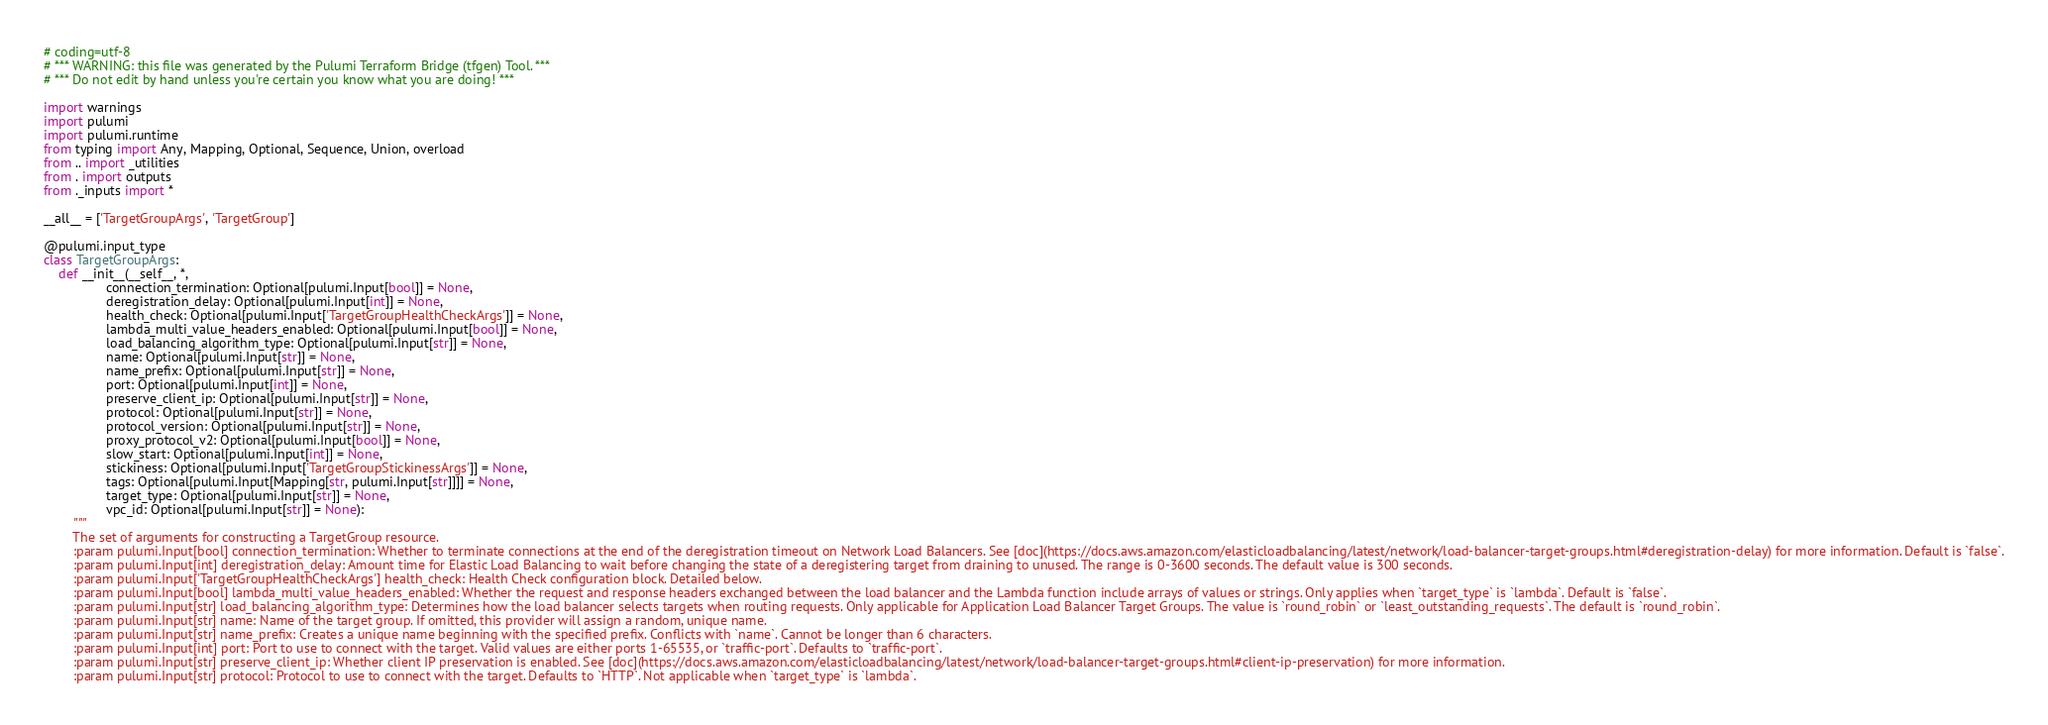Convert code to text. <code><loc_0><loc_0><loc_500><loc_500><_Python_># coding=utf-8
# *** WARNING: this file was generated by the Pulumi Terraform Bridge (tfgen) Tool. ***
# *** Do not edit by hand unless you're certain you know what you are doing! ***

import warnings
import pulumi
import pulumi.runtime
from typing import Any, Mapping, Optional, Sequence, Union, overload
from .. import _utilities
from . import outputs
from ._inputs import *

__all__ = ['TargetGroupArgs', 'TargetGroup']

@pulumi.input_type
class TargetGroupArgs:
    def __init__(__self__, *,
                 connection_termination: Optional[pulumi.Input[bool]] = None,
                 deregistration_delay: Optional[pulumi.Input[int]] = None,
                 health_check: Optional[pulumi.Input['TargetGroupHealthCheckArgs']] = None,
                 lambda_multi_value_headers_enabled: Optional[pulumi.Input[bool]] = None,
                 load_balancing_algorithm_type: Optional[pulumi.Input[str]] = None,
                 name: Optional[pulumi.Input[str]] = None,
                 name_prefix: Optional[pulumi.Input[str]] = None,
                 port: Optional[pulumi.Input[int]] = None,
                 preserve_client_ip: Optional[pulumi.Input[str]] = None,
                 protocol: Optional[pulumi.Input[str]] = None,
                 protocol_version: Optional[pulumi.Input[str]] = None,
                 proxy_protocol_v2: Optional[pulumi.Input[bool]] = None,
                 slow_start: Optional[pulumi.Input[int]] = None,
                 stickiness: Optional[pulumi.Input['TargetGroupStickinessArgs']] = None,
                 tags: Optional[pulumi.Input[Mapping[str, pulumi.Input[str]]]] = None,
                 target_type: Optional[pulumi.Input[str]] = None,
                 vpc_id: Optional[pulumi.Input[str]] = None):
        """
        The set of arguments for constructing a TargetGroup resource.
        :param pulumi.Input[bool] connection_termination: Whether to terminate connections at the end of the deregistration timeout on Network Load Balancers. See [doc](https://docs.aws.amazon.com/elasticloadbalancing/latest/network/load-balancer-target-groups.html#deregistration-delay) for more information. Default is `false`.
        :param pulumi.Input[int] deregistration_delay: Amount time for Elastic Load Balancing to wait before changing the state of a deregistering target from draining to unused. The range is 0-3600 seconds. The default value is 300 seconds.
        :param pulumi.Input['TargetGroupHealthCheckArgs'] health_check: Health Check configuration block. Detailed below.
        :param pulumi.Input[bool] lambda_multi_value_headers_enabled: Whether the request and response headers exchanged between the load balancer and the Lambda function include arrays of values or strings. Only applies when `target_type` is `lambda`. Default is `false`.
        :param pulumi.Input[str] load_balancing_algorithm_type: Determines how the load balancer selects targets when routing requests. Only applicable for Application Load Balancer Target Groups. The value is `round_robin` or `least_outstanding_requests`. The default is `round_robin`.
        :param pulumi.Input[str] name: Name of the target group. If omitted, this provider will assign a random, unique name.
        :param pulumi.Input[str] name_prefix: Creates a unique name beginning with the specified prefix. Conflicts with `name`. Cannot be longer than 6 characters.
        :param pulumi.Input[int] port: Port to use to connect with the target. Valid values are either ports 1-65535, or `traffic-port`. Defaults to `traffic-port`.
        :param pulumi.Input[str] preserve_client_ip: Whether client IP preservation is enabled. See [doc](https://docs.aws.amazon.com/elasticloadbalancing/latest/network/load-balancer-target-groups.html#client-ip-preservation) for more information.
        :param pulumi.Input[str] protocol: Protocol to use to connect with the target. Defaults to `HTTP`. Not applicable when `target_type` is `lambda`.</code> 